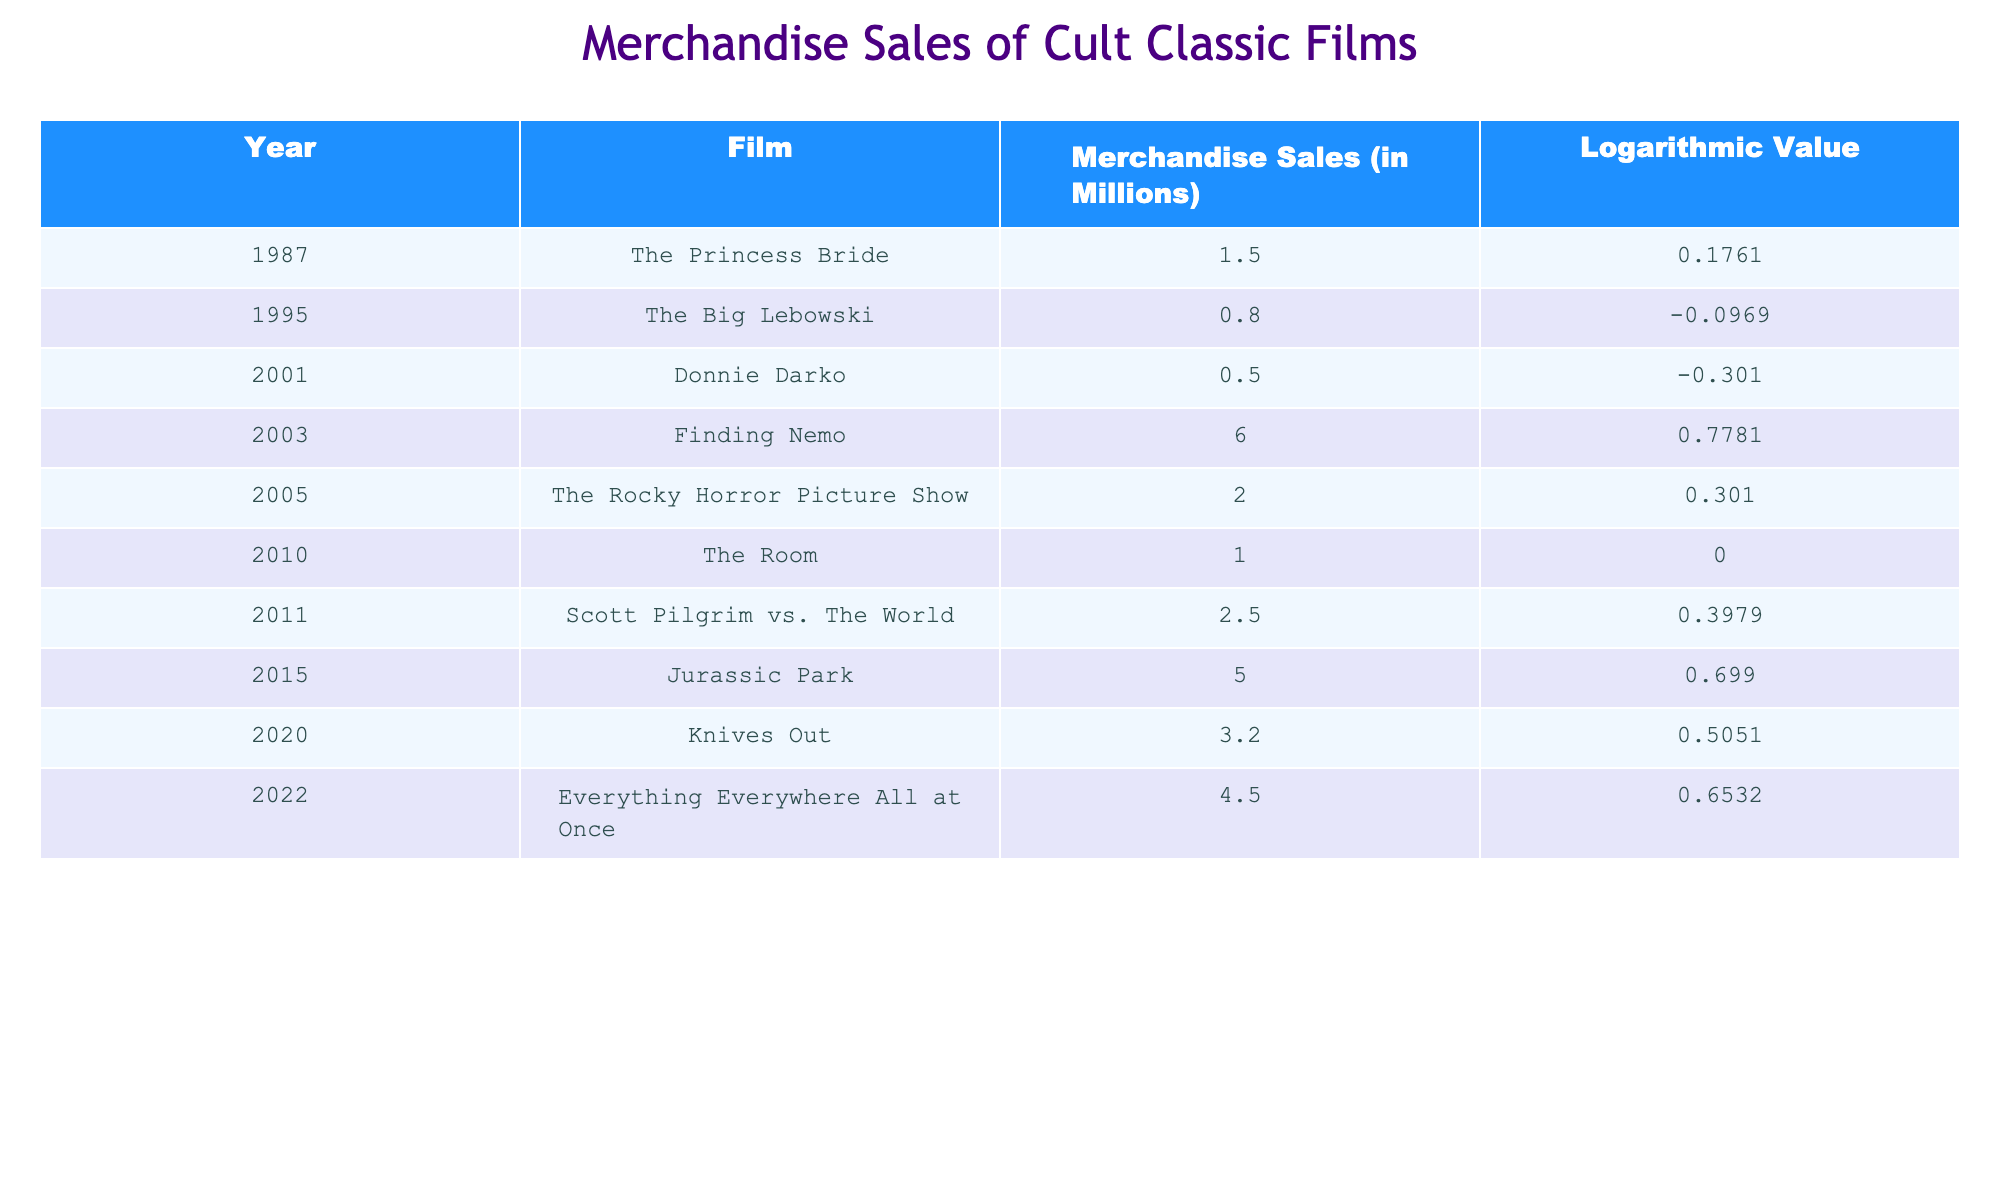What were the merchandise sales for "The Princess Bride"? The table displays the merchandise sales in millions for each film. For "The Princess Bride," the sales are listed as 1.5 million.
Answer: 1.5 million Which film had the lowest merchandise sales? By reviewing the merchandise sales column, it can be observed that "Donnie Darko" had the lowest sales with 0.5 million.
Answer: Donnie Darko What is the difference in merchandise sales between "Jurassic Park" and "The Big Lebowski"? The sales for "Jurassic Park" are 5.0 million, and for "The Big Lebowski," they are 0.8 million. The difference is 5.0 - 0.8 = 4.2 million.
Answer: 4.2 million Is it true that "Everything Everywhere All at Once" had merchandise sales exceeding 4 million? The sales for "Everything Everywhere All at Once" are listed as 4.5 million, which is higher than 4 million. Therefore, the statement is true.
Answer: Yes What was the average merchandise sales for the films released between 2000 and 2010? The films in that range are "Donnie Darko" (0.5 million), "Finding Nemo" (6.0 million), "The Room" (1.0 million), "Scott Pilgrim vs. The World" (2.5 million), and "Jurassic Park" (5.0 million). The total is 0.5 + 6.0 + 1.0 + 2.5 + 5.0 = 15 million for 5 films, so the average is 15/5 = 3 million.
Answer: 3 million Which film had a higher logarithmic value: "The Room" or "Finding Nemo"? The logarithmic values for "Finding Nemo" is 0.7781, while for "The Room" is 0.0000. Comparing these, 0.7781 is greater than 0.0000, indicating "Finding Nemo" had a higher value.
Answer: Finding Nemo What is the total merchandise sales for all films in the year 2003 and later? The films from 2003 onward are "Finding Nemo" (6.0 million), "The Rocky Horror Picture Show" (2.0 million), "The Room" (1.0 million), "Scott Pilgrim vs. The World" (2.5 million), "Jurassic Park" (5.0 million), "Knives Out" (3.2 million), and "Everything Everywhere All at Once" (4.5 million). The sum is 6.0 + 2.0 + 1.0 + 2.5 + 5.0 + 3.2 + 4.5 = 24.2 million.
Answer: 24.2 million Was the logarithmic value for "The Big Lebowski" greater than 0? The logarithmic value for "The Big Lebowski" is -0.0969, which is less than 0, making the statement false.
Answer: No 